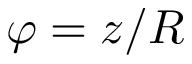<formula> <loc_0><loc_0><loc_500><loc_500>\varphi = z / R</formula> 